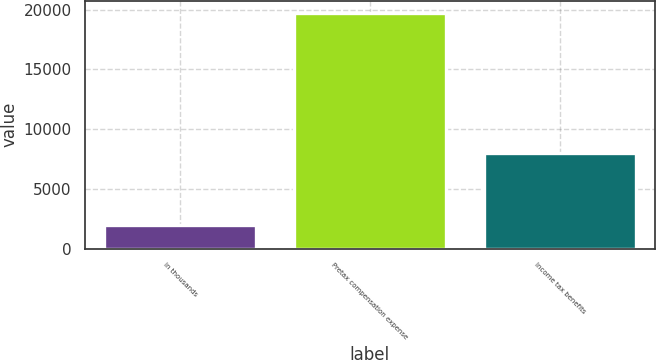Convert chart. <chart><loc_0><loc_0><loc_500><loc_500><bar_chart><fcel>in thousands<fcel>Pretax compensation expense<fcel>Income tax benefits<nl><fcel>2010<fcel>19746<fcel>7968<nl></chart> 